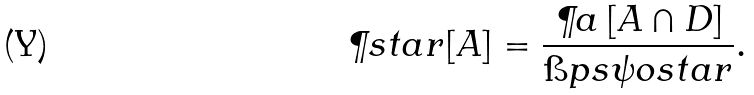Convert formula to latex. <formula><loc_0><loc_0><loc_500><loc_500>\P s t a r [ A ] & = \frac { \P a \left [ A \cap D \right ] } { \i p { s } { \psi o s t a r } } .</formula> 